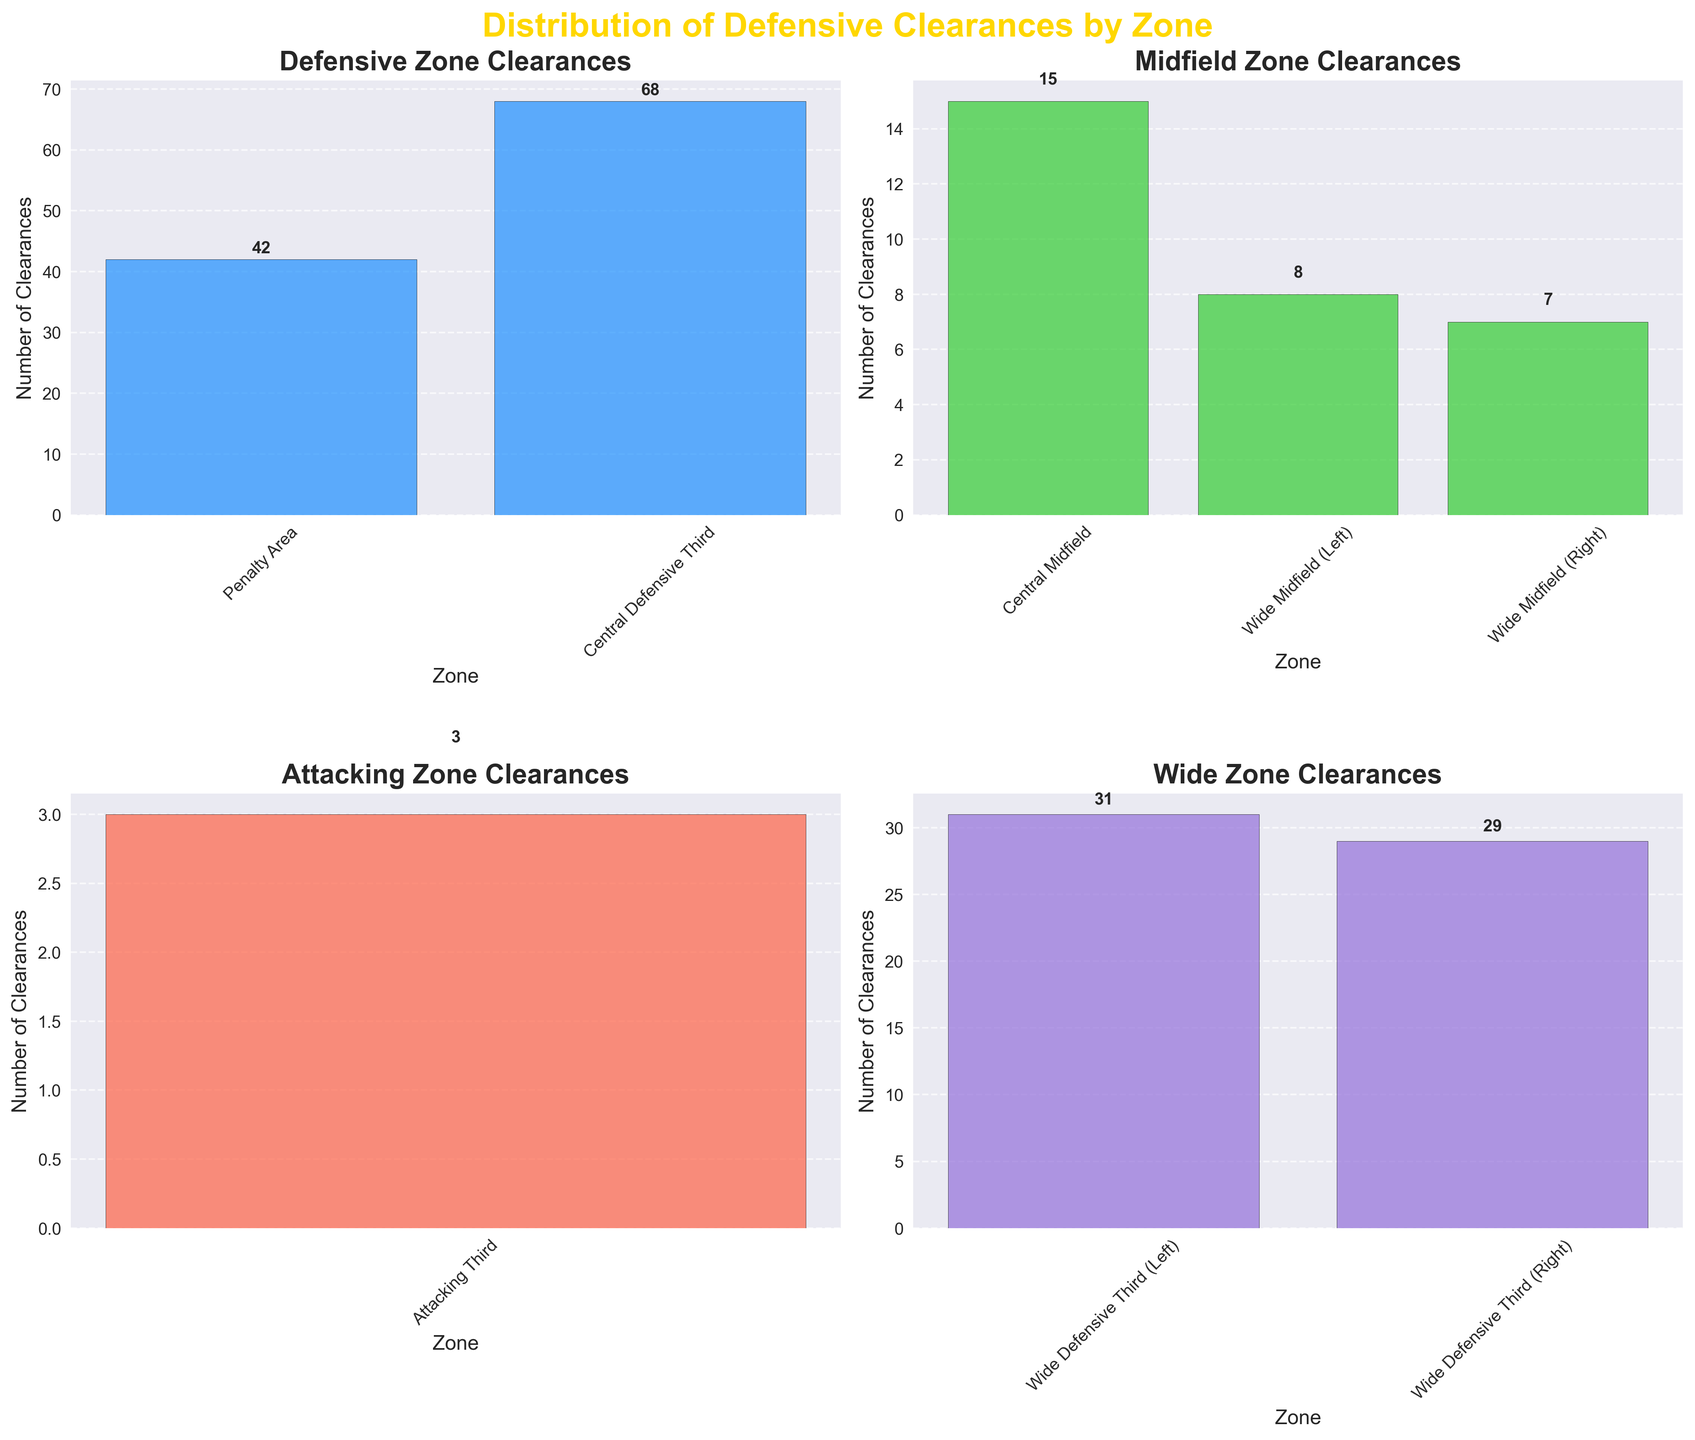What are the zones mentioned in the figure titles? The figure is divided into four subplots, each covering a different zone: Defensive Zone, Midfield Zone, Attacking Zone, and Wide Zone.
Answer: Defensive, Midfield, Attacking, Wide How many clearances are made in the Penalty Area? Looking at the bar in the "Defensive Zone Clearances" subplot, it shows that the Penalty Area has 42 clearances.
Answer: 42 Which zone has the highest number of clearances? Observing all the subplots, the "Central Defensive Third" in the Defensive Zone has the highest number of clearances with 68.
Answer: Central Defensive Third What is the combined number of clearances in the Wide Midfield zones? Looking at the Wide Midfield (Left) and Wide Midfield (Right) in the Midfield Zone subplot, the clearances are 8 and 7 respectively. The sum is 8 + 7 = 15.
Answer: 15 How do the clearances in the Central Midfield compare to those in the Attacking Third? Comparing the values, Central Midfield has 15 clearances and Attacking Third has 3 clearances. The Central Midfield has more clearances than the Attacking Third.
Answer: Central Midfield has more Which defensive zone has fewer clearances: Penalty Area or Central Defensive Third? Looking at the bar heights in the Defensive Zone subplot, Penalty Area has 42 clearances while Central Defensive Third has 68. Thus, the Penalty Area has fewer clearances.
Answer: Penalty Area What is the average number of clearances in the Wide Defensive Third zones? The Wide Defensive Third (Left) has 31 clearances and Wide Defensive Third (Right) has 29, so the average is (31 + 29) / 2 = 30.
Answer: 30 Which zone has the least number of clearances, and how many? Observing all the bars across the subplots, the Attacking Third has the least number of clearances with a value of 3.
Answer: Attacking Third, 3 What's the total number of clearances in the Defensive Zone? Summing the values in the Defensive Zone subplot, Penalty Area (42) and Central Defensive Third (68) gives 42 + 68 = 110.
Answer: 110 Which wide zone has more clearances: Wide Defensive Third (Right) or Wide Midfield (Left)? Comparing the values, Wide Defensive Third (Right) has 29 clearances, while Wide Midfield (Left) has 8 clearances. Therefore, Wide Defensive Third (Right) has more clearances.
Answer: Wide Defensive Third (Right) 